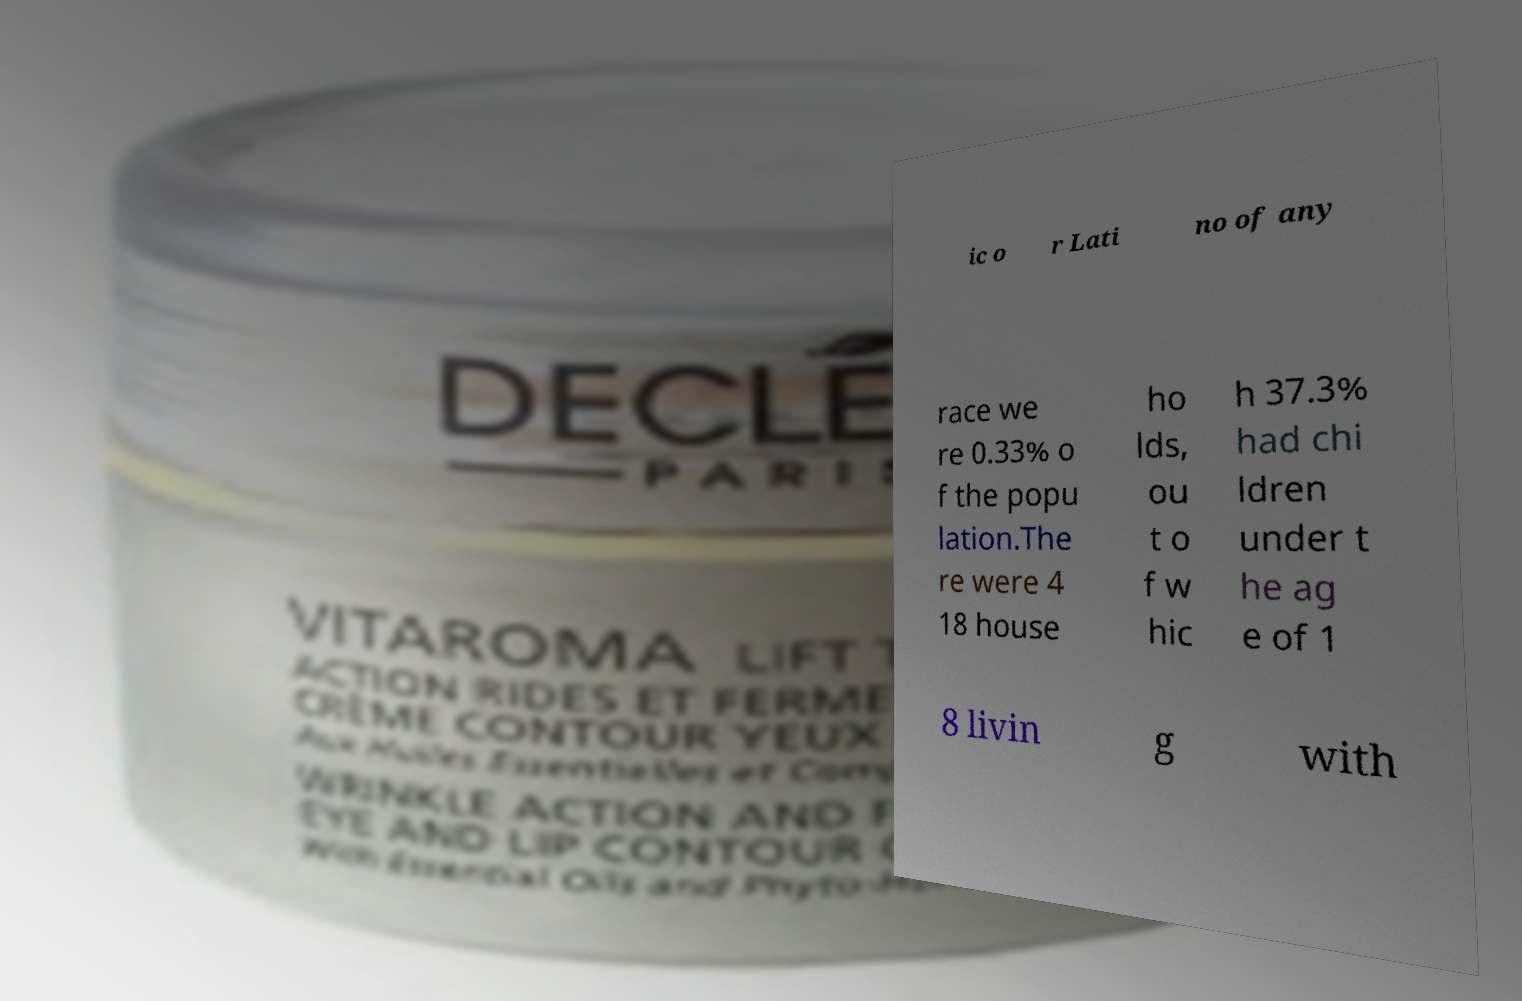Please read and relay the text visible in this image. What does it say? ic o r Lati no of any race we re 0.33% o f the popu lation.The re were 4 18 house ho lds, ou t o f w hic h 37.3% had chi ldren under t he ag e of 1 8 livin g with 